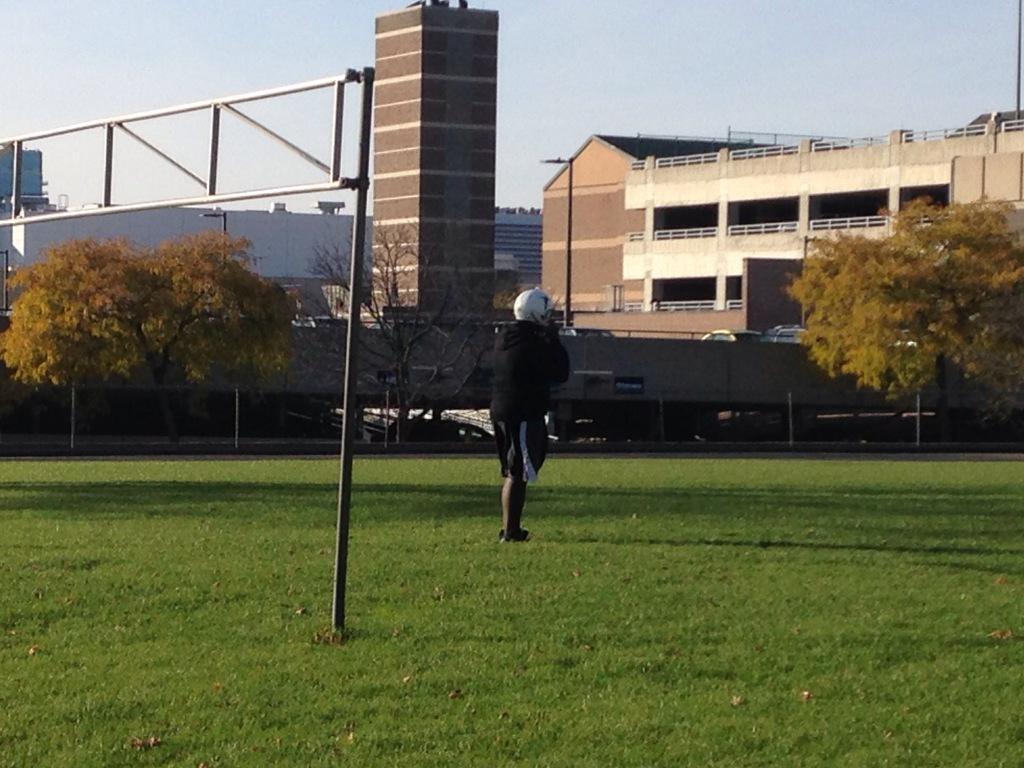Could you give a brief overview of what you see in this image? In this image I can see the grass. I can see a person. In the background, I can see the trees, buildings and the sky. 